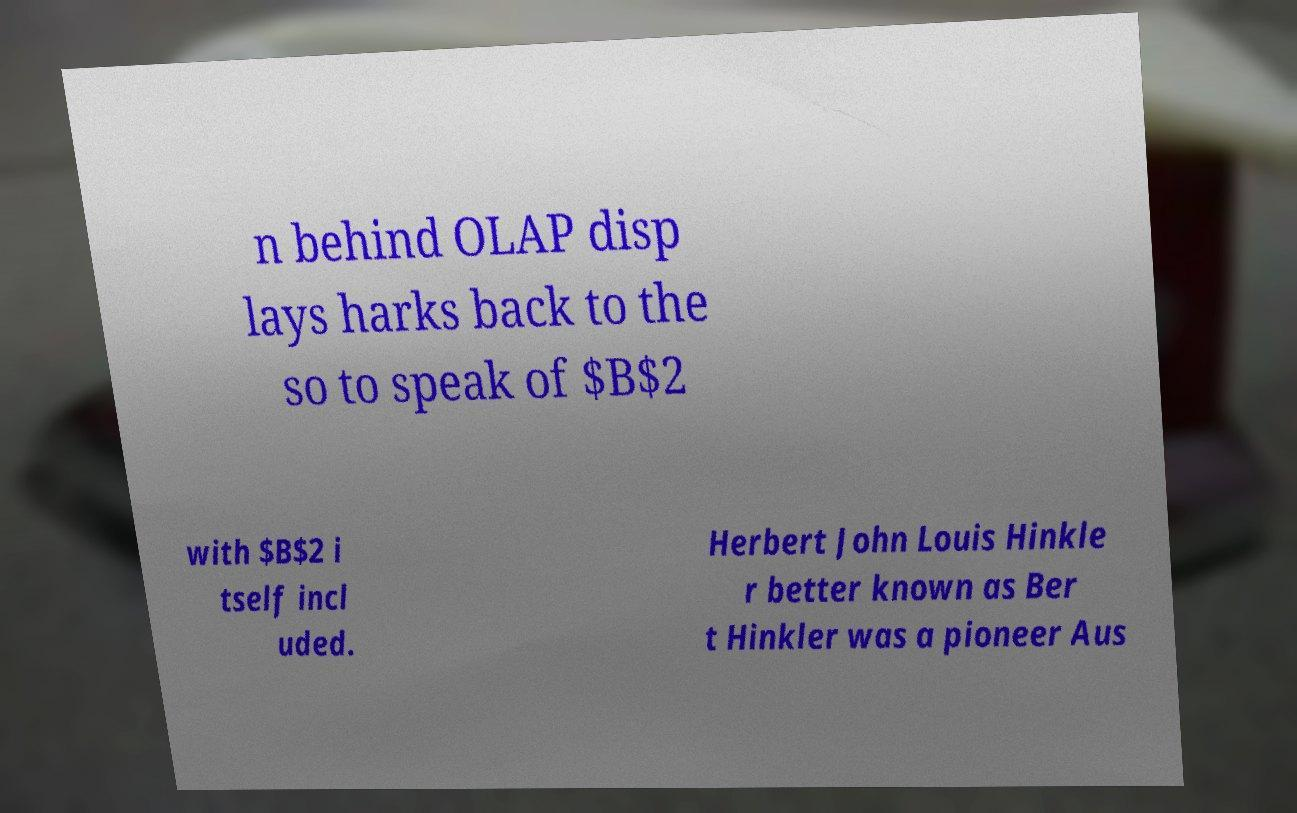I need the written content from this picture converted into text. Can you do that? n behind OLAP disp lays harks back to the so to speak of $B$2 with $B$2 i tself incl uded. Herbert John Louis Hinkle r better known as Ber t Hinkler was a pioneer Aus 